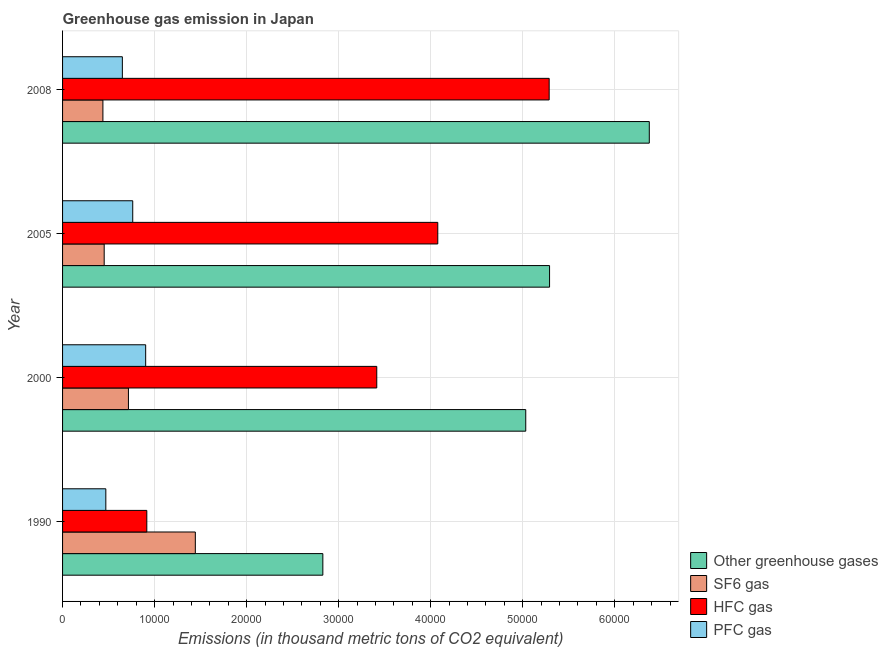How many groups of bars are there?
Give a very brief answer. 4. Are the number of bars per tick equal to the number of legend labels?
Offer a terse response. Yes. Are the number of bars on each tick of the Y-axis equal?
Provide a succinct answer. Yes. How many bars are there on the 1st tick from the bottom?
Offer a terse response. 4. In how many cases, is the number of bars for a given year not equal to the number of legend labels?
Your answer should be compact. 0. What is the emission of greenhouse gases in 2000?
Offer a terse response. 5.03e+04. Across all years, what is the maximum emission of pfc gas?
Your response must be concise. 9029.8. Across all years, what is the minimum emission of hfc gas?
Keep it short and to the point. 9154.3. In which year was the emission of pfc gas maximum?
Make the answer very short. 2000. What is the total emission of greenhouse gases in the graph?
Your response must be concise. 1.95e+05. What is the difference between the emission of greenhouse gases in 2000 and that in 2005?
Keep it short and to the point. -2588.2. What is the difference between the emission of greenhouse gases in 2008 and the emission of pfc gas in 2005?
Give a very brief answer. 5.61e+04. What is the average emission of greenhouse gases per year?
Give a very brief answer. 4.88e+04. In the year 2005, what is the difference between the emission of sf6 gas and emission of greenhouse gases?
Offer a terse response. -4.84e+04. In how many years, is the emission of pfc gas greater than 40000 thousand metric tons?
Make the answer very short. 0. What is the ratio of the emission of hfc gas in 2000 to that in 2005?
Make the answer very short. 0.84. What is the difference between the highest and the second highest emission of hfc gas?
Ensure brevity in your answer.  1.21e+04. What is the difference between the highest and the lowest emission of sf6 gas?
Make the answer very short. 1.00e+04. In how many years, is the emission of greenhouse gases greater than the average emission of greenhouse gases taken over all years?
Keep it short and to the point. 3. Is it the case that in every year, the sum of the emission of hfc gas and emission of greenhouse gases is greater than the sum of emission of pfc gas and emission of sf6 gas?
Offer a terse response. Yes. What does the 1st bar from the top in 2000 represents?
Your answer should be compact. PFC gas. What does the 3rd bar from the bottom in 2008 represents?
Provide a succinct answer. HFC gas. How many bars are there?
Ensure brevity in your answer.  16. How many years are there in the graph?
Keep it short and to the point. 4. What is the difference between two consecutive major ticks on the X-axis?
Your response must be concise. 10000. Are the values on the major ticks of X-axis written in scientific E-notation?
Make the answer very short. No. Does the graph contain grids?
Your response must be concise. Yes. Where does the legend appear in the graph?
Your answer should be compact. Bottom right. How are the legend labels stacked?
Keep it short and to the point. Vertical. What is the title of the graph?
Offer a very short reply. Greenhouse gas emission in Japan. What is the label or title of the X-axis?
Your answer should be very brief. Emissions (in thousand metric tons of CO2 equivalent). What is the Emissions (in thousand metric tons of CO2 equivalent) in Other greenhouse gases in 1990?
Offer a terse response. 2.83e+04. What is the Emissions (in thousand metric tons of CO2 equivalent) in SF6 gas in 1990?
Keep it short and to the point. 1.44e+04. What is the Emissions (in thousand metric tons of CO2 equivalent) in HFC gas in 1990?
Offer a terse response. 9154.3. What is the Emissions (in thousand metric tons of CO2 equivalent) in PFC gas in 1990?
Make the answer very short. 4700. What is the Emissions (in thousand metric tons of CO2 equivalent) of Other greenhouse gases in 2000?
Make the answer very short. 5.03e+04. What is the Emissions (in thousand metric tons of CO2 equivalent) in SF6 gas in 2000?
Offer a terse response. 7156.6. What is the Emissions (in thousand metric tons of CO2 equivalent) of HFC gas in 2000?
Your answer should be compact. 3.41e+04. What is the Emissions (in thousand metric tons of CO2 equivalent) of PFC gas in 2000?
Offer a very short reply. 9029.8. What is the Emissions (in thousand metric tons of CO2 equivalent) of Other greenhouse gases in 2005?
Your answer should be very brief. 5.29e+04. What is the Emissions (in thousand metric tons of CO2 equivalent) in SF6 gas in 2005?
Your response must be concise. 4522.3. What is the Emissions (in thousand metric tons of CO2 equivalent) of HFC gas in 2005?
Your response must be concise. 4.08e+04. What is the Emissions (in thousand metric tons of CO2 equivalent) of PFC gas in 2005?
Your answer should be very brief. 7623.6. What is the Emissions (in thousand metric tons of CO2 equivalent) of Other greenhouse gases in 2008?
Provide a short and direct response. 6.38e+04. What is the Emissions (in thousand metric tons of CO2 equivalent) of SF6 gas in 2008?
Offer a terse response. 4382.7. What is the Emissions (in thousand metric tons of CO2 equivalent) of HFC gas in 2008?
Provide a succinct answer. 5.29e+04. What is the Emissions (in thousand metric tons of CO2 equivalent) of PFC gas in 2008?
Keep it short and to the point. 6496.1. Across all years, what is the maximum Emissions (in thousand metric tons of CO2 equivalent) of Other greenhouse gases?
Make the answer very short. 6.38e+04. Across all years, what is the maximum Emissions (in thousand metric tons of CO2 equivalent) of SF6 gas?
Ensure brevity in your answer.  1.44e+04. Across all years, what is the maximum Emissions (in thousand metric tons of CO2 equivalent) in HFC gas?
Make the answer very short. 5.29e+04. Across all years, what is the maximum Emissions (in thousand metric tons of CO2 equivalent) of PFC gas?
Provide a short and direct response. 9029.8. Across all years, what is the minimum Emissions (in thousand metric tons of CO2 equivalent) in Other greenhouse gases?
Offer a very short reply. 2.83e+04. Across all years, what is the minimum Emissions (in thousand metric tons of CO2 equivalent) of SF6 gas?
Provide a succinct answer. 4382.7. Across all years, what is the minimum Emissions (in thousand metric tons of CO2 equivalent) of HFC gas?
Provide a short and direct response. 9154.3. Across all years, what is the minimum Emissions (in thousand metric tons of CO2 equivalent) of PFC gas?
Provide a succinct answer. 4700. What is the total Emissions (in thousand metric tons of CO2 equivalent) of Other greenhouse gases in the graph?
Your answer should be compact. 1.95e+05. What is the total Emissions (in thousand metric tons of CO2 equivalent) in SF6 gas in the graph?
Offer a terse response. 3.05e+04. What is the total Emissions (in thousand metric tons of CO2 equivalent) in HFC gas in the graph?
Offer a terse response. 1.37e+05. What is the total Emissions (in thousand metric tons of CO2 equivalent) in PFC gas in the graph?
Your answer should be very brief. 2.78e+04. What is the difference between the Emissions (in thousand metric tons of CO2 equivalent) of Other greenhouse gases in 1990 and that in 2000?
Your answer should be very brief. -2.20e+04. What is the difference between the Emissions (in thousand metric tons of CO2 equivalent) of SF6 gas in 1990 and that in 2000?
Offer a very short reply. 7269.2. What is the difference between the Emissions (in thousand metric tons of CO2 equivalent) in HFC gas in 1990 and that in 2000?
Offer a terse response. -2.50e+04. What is the difference between the Emissions (in thousand metric tons of CO2 equivalent) in PFC gas in 1990 and that in 2000?
Provide a succinct answer. -4329.8. What is the difference between the Emissions (in thousand metric tons of CO2 equivalent) of Other greenhouse gases in 1990 and that in 2005?
Give a very brief answer. -2.46e+04. What is the difference between the Emissions (in thousand metric tons of CO2 equivalent) in SF6 gas in 1990 and that in 2005?
Give a very brief answer. 9903.5. What is the difference between the Emissions (in thousand metric tons of CO2 equivalent) of HFC gas in 1990 and that in 2005?
Provide a succinct answer. -3.16e+04. What is the difference between the Emissions (in thousand metric tons of CO2 equivalent) of PFC gas in 1990 and that in 2005?
Offer a terse response. -2923.6. What is the difference between the Emissions (in thousand metric tons of CO2 equivalent) of Other greenhouse gases in 1990 and that in 2008?
Provide a short and direct response. -3.55e+04. What is the difference between the Emissions (in thousand metric tons of CO2 equivalent) of SF6 gas in 1990 and that in 2008?
Offer a very short reply. 1.00e+04. What is the difference between the Emissions (in thousand metric tons of CO2 equivalent) of HFC gas in 1990 and that in 2008?
Your answer should be very brief. -4.37e+04. What is the difference between the Emissions (in thousand metric tons of CO2 equivalent) in PFC gas in 1990 and that in 2008?
Ensure brevity in your answer.  -1796.1. What is the difference between the Emissions (in thousand metric tons of CO2 equivalent) of Other greenhouse gases in 2000 and that in 2005?
Provide a short and direct response. -2588.2. What is the difference between the Emissions (in thousand metric tons of CO2 equivalent) of SF6 gas in 2000 and that in 2005?
Provide a short and direct response. 2634.3. What is the difference between the Emissions (in thousand metric tons of CO2 equivalent) in HFC gas in 2000 and that in 2005?
Your answer should be very brief. -6628.7. What is the difference between the Emissions (in thousand metric tons of CO2 equivalent) of PFC gas in 2000 and that in 2005?
Keep it short and to the point. 1406.2. What is the difference between the Emissions (in thousand metric tons of CO2 equivalent) in Other greenhouse gases in 2000 and that in 2008?
Offer a very short reply. -1.34e+04. What is the difference between the Emissions (in thousand metric tons of CO2 equivalent) in SF6 gas in 2000 and that in 2008?
Offer a very short reply. 2773.9. What is the difference between the Emissions (in thousand metric tons of CO2 equivalent) of HFC gas in 2000 and that in 2008?
Make the answer very short. -1.87e+04. What is the difference between the Emissions (in thousand metric tons of CO2 equivalent) in PFC gas in 2000 and that in 2008?
Offer a very short reply. 2533.7. What is the difference between the Emissions (in thousand metric tons of CO2 equivalent) in Other greenhouse gases in 2005 and that in 2008?
Ensure brevity in your answer.  -1.08e+04. What is the difference between the Emissions (in thousand metric tons of CO2 equivalent) in SF6 gas in 2005 and that in 2008?
Make the answer very short. 139.6. What is the difference between the Emissions (in thousand metric tons of CO2 equivalent) of HFC gas in 2005 and that in 2008?
Your answer should be compact. -1.21e+04. What is the difference between the Emissions (in thousand metric tons of CO2 equivalent) in PFC gas in 2005 and that in 2008?
Offer a terse response. 1127.5. What is the difference between the Emissions (in thousand metric tons of CO2 equivalent) of Other greenhouse gases in 1990 and the Emissions (in thousand metric tons of CO2 equivalent) of SF6 gas in 2000?
Your answer should be very brief. 2.11e+04. What is the difference between the Emissions (in thousand metric tons of CO2 equivalent) of Other greenhouse gases in 1990 and the Emissions (in thousand metric tons of CO2 equivalent) of HFC gas in 2000?
Offer a very short reply. -5859.7. What is the difference between the Emissions (in thousand metric tons of CO2 equivalent) in Other greenhouse gases in 1990 and the Emissions (in thousand metric tons of CO2 equivalent) in PFC gas in 2000?
Give a very brief answer. 1.93e+04. What is the difference between the Emissions (in thousand metric tons of CO2 equivalent) of SF6 gas in 1990 and the Emissions (in thousand metric tons of CO2 equivalent) of HFC gas in 2000?
Offer a very short reply. -1.97e+04. What is the difference between the Emissions (in thousand metric tons of CO2 equivalent) in SF6 gas in 1990 and the Emissions (in thousand metric tons of CO2 equivalent) in PFC gas in 2000?
Provide a short and direct response. 5396. What is the difference between the Emissions (in thousand metric tons of CO2 equivalent) in HFC gas in 1990 and the Emissions (in thousand metric tons of CO2 equivalent) in PFC gas in 2000?
Ensure brevity in your answer.  124.5. What is the difference between the Emissions (in thousand metric tons of CO2 equivalent) in Other greenhouse gases in 1990 and the Emissions (in thousand metric tons of CO2 equivalent) in SF6 gas in 2005?
Offer a very short reply. 2.38e+04. What is the difference between the Emissions (in thousand metric tons of CO2 equivalent) in Other greenhouse gases in 1990 and the Emissions (in thousand metric tons of CO2 equivalent) in HFC gas in 2005?
Make the answer very short. -1.25e+04. What is the difference between the Emissions (in thousand metric tons of CO2 equivalent) of Other greenhouse gases in 1990 and the Emissions (in thousand metric tons of CO2 equivalent) of PFC gas in 2005?
Keep it short and to the point. 2.07e+04. What is the difference between the Emissions (in thousand metric tons of CO2 equivalent) in SF6 gas in 1990 and the Emissions (in thousand metric tons of CO2 equivalent) in HFC gas in 2005?
Keep it short and to the point. -2.63e+04. What is the difference between the Emissions (in thousand metric tons of CO2 equivalent) of SF6 gas in 1990 and the Emissions (in thousand metric tons of CO2 equivalent) of PFC gas in 2005?
Ensure brevity in your answer.  6802.2. What is the difference between the Emissions (in thousand metric tons of CO2 equivalent) of HFC gas in 1990 and the Emissions (in thousand metric tons of CO2 equivalent) of PFC gas in 2005?
Provide a succinct answer. 1530.7. What is the difference between the Emissions (in thousand metric tons of CO2 equivalent) in Other greenhouse gases in 1990 and the Emissions (in thousand metric tons of CO2 equivalent) in SF6 gas in 2008?
Give a very brief answer. 2.39e+04. What is the difference between the Emissions (in thousand metric tons of CO2 equivalent) of Other greenhouse gases in 1990 and the Emissions (in thousand metric tons of CO2 equivalent) of HFC gas in 2008?
Ensure brevity in your answer.  -2.46e+04. What is the difference between the Emissions (in thousand metric tons of CO2 equivalent) in Other greenhouse gases in 1990 and the Emissions (in thousand metric tons of CO2 equivalent) in PFC gas in 2008?
Your response must be concise. 2.18e+04. What is the difference between the Emissions (in thousand metric tons of CO2 equivalent) in SF6 gas in 1990 and the Emissions (in thousand metric tons of CO2 equivalent) in HFC gas in 2008?
Give a very brief answer. -3.84e+04. What is the difference between the Emissions (in thousand metric tons of CO2 equivalent) in SF6 gas in 1990 and the Emissions (in thousand metric tons of CO2 equivalent) in PFC gas in 2008?
Give a very brief answer. 7929.7. What is the difference between the Emissions (in thousand metric tons of CO2 equivalent) in HFC gas in 1990 and the Emissions (in thousand metric tons of CO2 equivalent) in PFC gas in 2008?
Your answer should be very brief. 2658.2. What is the difference between the Emissions (in thousand metric tons of CO2 equivalent) of Other greenhouse gases in 2000 and the Emissions (in thousand metric tons of CO2 equivalent) of SF6 gas in 2005?
Provide a short and direct response. 4.58e+04. What is the difference between the Emissions (in thousand metric tons of CO2 equivalent) of Other greenhouse gases in 2000 and the Emissions (in thousand metric tons of CO2 equivalent) of HFC gas in 2005?
Give a very brief answer. 9557.7. What is the difference between the Emissions (in thousand metric tons of CO2 equivalent) in Other greenhouse gases in 2000 and the Emissions (in thousand metric tons of CO2 equivalent) in PFC gas in 2005?
Give a very brief answer. 4.27e+04. What is the difference between the Emissions (in thousand metric tons of CO2 equivalent) of SF6 gas in 2000 and the Emissions (in thousand metric tons of CO2 equivalent) of HFC gas in 2005?
Keep it short and to the point. -3.36e+04. What is the difference between the Emissions (in thousand metric tons of CO2 equivalent) of SF6 gas in 2000 and the Emissions (in thousand metric tons of CO2 equivalent) of PFC gas in 2005?
Ensure brevity in your answer.  -467. What is the difference between the Emissions (in thousand metric tons of CO2 equivalent) in HFC gas in 2000 and the Emissions (in thousand metric tons of CO2 equivalent) in PFC gas in 2005?
Your response must be concise. 2.65e+04. What is the difference between the Emissions (in thousand metric tons of CO2 equivalent) in Other greenhouse gases in 2000 and the Emissions (in thousand metric tons of CO2 equivalent) in SF6 gas in 2008?
Provide a succinct answer. 4.59e+04. What is the difference between the Emissions (in thousand metric tons of CO2 equivalent) of Other greenhouse gases in 2000 and the Emissions (in thousand metric tons of CO2 equivalent) of HFC gas in 2008?
Ensure brevity in your answer.  -2545.7. What is the difference between the Emissions (in thousand metric tons of CO2 equivalent) of Other greenhouse gases in 2000 and the Emissions (in thousand metric tons of CO2 equivalent) of PFC gas in 2008?
Offer a terse response. 4.38e+04. What is the difference between the Emissions (in thousand metric tons of CO2 equivalent) in SF6 gas in 2000 and the Emissions (in thousand metric tons of CO2 equivalent) in HFC gas in 2008?
Your response must be concise. -4.57e+04. What is the difference between the Emissions (in thousand metric tons of CO2 equivalent) in SF6 gas in 2000 and the Emissions (in thousand metric tons of CO2 equivalent) in PFC gas in 2008?
Provide a short and direct response. 660.5. What is the difference between the Emissions (in thousand metric tons of CO2 equivalent) of HFC gas in 2000 and the Emissions (in thousand metric tons of CO2 equivalent) of PFC gas in 2008?
Give a very brief answer. 2.76e+04. What is the difference between the Emissions (in thousand metric tons of CO2 equivalent) of Other greenhouse gases in 2005 and the Emissions (in thousand metric tons of CO2 equivalent) of SF6 gas in 2008?
Keep it short and to the point. 4.85e+04. What is the difference between the Emissions (in thousand metric tons of CO2 equivalent) in Other greenhouse gases in 2005 and the Emissions (in thousand metric tons of CO2 equivalent) in HFC gas in 2008?
Offer a terse response. 42.5. What is the difference between the Emissions (in thousand metric tons of CO2 equivalent) in Other greenhouse gases in 2005 and the Emissions (in thousand metric tons of CO2 equivalent) in PFC gas in 2008?
Offer a terse response. 4.64e+04. What is the difference between the Emissions (in thousand metric tons of CO2 equivalent) in SF6 gas in 2005 and the Emissions (in thousand metric tons of CO2 equivalent) in HFC gas in 2008?
Make the answer very short. -4.83e+04. What is the difference between the Emissions (in thousand metric tons of CO2 equivalent) of SF6 gas in 2005 and the Emissions (in thousand metric tons of CO2 equivalent) of PFC gas in 2008?
Give a very brief answer. -1973.8. What is the difference between the Emissions (in thousand metric tons of CO2 equivalent) of HFC gas in 2005 and the Emissions (in thousand metric tons of CO2 equivalent) of PFC gas in 2008?
Ensure brevity in your answer.  3.43e+04. What is the average Emissions (in thousand metric tons of CO2 equivalent) of Other greenhouse gases per year?
Provide a short and direct response. 4.88e+04. What is the average Emissions (in thousand metric tons of CO2 equivalent) in SF6 gas per year?
Make the answer very short. 7621.85. What is the average Emissions (in thousand metric tons of CO2 equivalent) of HFC gas per year?
Offer a terse response. 3.42e+04. What is the average Emissions (in thousand metric tons of CO2 equivalent) in PFC gas per year?
Offer a very short reply. 6962.38. In the year 1990, what is the difference between the Emissions (in thousand metric tons of CO2 equivalent) in Other greenhouse gases and Emissions (in thousand metric tons of CO2 equivalent) in SF6 gas?
Offer a very short reply. 1.39e+04. In the year 1990, what is the difference between the Emissions (in thousand metric tons of CO2 equivalent) of Other greenhouse gases and Emissions (in thousand metric tons of CO2 equivalent) of HFC gas?
Provide a succinct answer. 1.91e+04. In the year 1990, what is the difference between the Emissions (in thousand metric tons of CO2 equivalent) in Other greenhouse gases and Emissions (in thousand metric tons of CO2 equivalent) in PFC gas?
Your response must be concise. 2.36e+04. In the year 1990, what is the difference between the Emissions (in thousand metric tons of CO2 equivalent) in SF6 gas and Emissions (in thousand metric tons of CO2 equivalent) in HFC gas?
Your answer should be very brief. 5271.5. In the year 1990, what is the difference between the Emissions (in thousand metric tons of CO2 equivalent) in SF6 gas and Emissions (in thousand metric tons of CO2 equivalent) in PFC gas?
Your response must be concise. 9725.8. In the year 1990, what is the difference between the Emissions (in thousand metric tons of CO2 equivalent) of HFC gas and Emissions (in thousand metric tons of CO2 equivalent) of PFC gas?
Offer a very short reply. 4454.3. In the year 2000, what is the difference between the Emissions (in thousand metric tons of CO2 equivalent) in Other greenhouse gases and Emissions (in thousand metric tons of CO2 equivalent) in SF6 gas?
Make the answer very short. 4.32e+04. In the year 2000, what is the difference between the Emissions (in thousand metric tons of CO2 equivalent) in Other greenhouse gases and Emissions (in thousand metric tons of CO2 equivalent) in HFC gas?
Provide a succinct answer. 1.62e+04. In the year 2000, what is the difference between the Emissions (in thousand metric tons of CO2 equivalent) in Other greenhouse gases and Emissions (in thousand metric tons of CO2 equivalent) in PFC gas?
Keep it short and to the point. 4.13e+04. In the year 2000, what is the difference between the Emissions (in thousand metric tons of CO2 equivalent) in SF6 gas and Emissions (in thousand metric tons of CO2 equivalent) in HFC gas?
Make the answer very short. -2.70e+04. In the year 2000, what is the difference between the Emissions (in thousand metric tons of CO2 equivalent) of SF6 gas and Emissions (in thousand metric tons of CO2 equivalent) of PFC gas?
Provide a succinct answer. -1873.2. In the year 2000, what is the difference between the Emissions (in thousand metric tons of CO2 equivalent) of HFC gas and Emissions (in thousand metric tons of CO2 equivalent) of PFC gas?
Provide a short and direct response. 2.51e+04. In the year 2005, what is the difference between the Emissions (in thousand metric tons of CO2 equivalent) in Other greenhouse gases and Emissions (in thousand metric tons of CO2 equivalent) in SF6 gas?
Your answer should be very brief. 4.84e+04. In the year 2005, what is the difference between the Emissions (in thousand metric tons of CO2 equivalent) of Other greenhouse gases and Emissions (in thousand metric tons of CO2 equivalent) of HFC gas?
Keep it short and to the point. 1.21e+04. In the year 2005, what is the difference between the Emissions (in thousand metric tons of CO2 equivalent) in Other greenhouse gases and Emissions (in thousand metric tons of CO2 equivalent) in PFC gas?
Your answer should be compact. 4.53e+04. In the year 2005, what is the difference between the Emissions (in thousand metric tons of CO2 equivalent) of SF6 gas and Emissions (in thousand metric tons of CO2 equivalent) of HFC gas?
Provide a succinct answer. -3.62e+04. In the year 2005, what is the difference between the Emissions (in thousand metric tons of CO2 equivalent) of SF6 gas and Emissions (in thousand metric tons of CO2 equivalent) of PFC gas?
Your answer should be very brief. -3101.3. In the year 2005, what is the difference between the Emissions (in thousand metric tons of CO2 equivalent) in HFC gas and Emissions (in thousand metric tons of CO2 equivalent) in PFC gas?
Your response must be concise. 3.31e+04. In the year 2008, what is the difference between the Emissions (in thousand metric tons of CO2 equivalent) in Other greenhouse gases and Emissions (in thousand metric tons of CO2 equivalent) in SF6 gas?
Offer a very short reply. 5.94e+04. In the year 2008, what is the difference between the Emissions (in thousand metric tons of CO2 equivalent) in Other greenhouse gases and Emissions (in thousand metric tons of CO2 equivalent) in HFC gas?
Provide a succinct answer. 1.09e+04. In the year 2008, what is the difference between the Emissions (in thousand metric tons of CO2 equivalent) in Other greenhouse gases and Emissions (in thousand metric tons of CO2 equivalent) in PFC gas?
Provide a short and direct response. 5.73e+04. In the year 2008, what is the difference between the Emissions (in thousand metric tons of CO2 equivalent) of SF6 gas and Emissions (in thousand metric tons of CO2 equivalent) of HFC gas?
Your response must be concise. -4.85e+04. In the year 2008, what is the difference between the Emissions (in thousand metric tons of CO2 equivalent) in SF6 gas and Emissions (in thousand metric tons of CO2 equivalent) in PFC gas?
Provide a short and direct response. -2113.4. In the year 2008, what is the difference between the Emissions (in thousand metric tons of CO2 equivalent) in HFC gas and Emissions (in thousand metric tons of CO2 equivalent) in PFC gas?
Offer a terse response. 4.64e+04. What is the ratio of the Emissions (in thousand metric tons of CO2 equivalent) in Other greenhouse gases in 1990 to that in 2000?
Ensure brevity in your answer.  0.56. What is the ratio of the Emissions (in thousand metric tons of CO2 equivalent) in SF6 gas in 1990 to that in 2000?
Ensure brevity in your answer.  2.02. What is the ratio of the Emissions (in thousand metric tons of CO2 equivalent) of HFC gas in 1990 to that in 2000?
Offer a very short reply. 0.27. What is the ratio of the Emissions (in thousand metric tons of CO2 equivalent) in PFC gas in 1990 to that in 2000?
Make the answer very short. 0.52. What is the ratio of the Emissions (in thousand metric tons of CO2 equivalent) in Other greenhouse gases in 1990 to that in 2005?
Offer a very short reply. 0.53. What is the ratio of the Emissions (in thousand metric tons of CO2 equivalent) in SF6 gas in 1990 to that in 2005?
Your answer should be compact. 3.19. What is the ratio of the Emissions (in thousand metric tons of CO2 equivalent) of HFC gas in 1990 to that in 2005?
Give a very brief answer. 0.22. What is the ratio of the Emissions (in thousand metric tons of CO2 equivalent) in PFC gas in 1990 to that in 2005?
Your answer should be very brief. 0.62. What is the ratio of the Emissions (in thousand metric tons of CO2 equivalent) in Other greenhouse gases in 1990 to that in 2008?
Your response must be concise. 0.44. What is the ratio of the Emissions (in thousand metric tons of CO2 equivalent) of SF6 gas in 1990 to that in 2008?
Your answer should be very brief. 3.29. What is the ratio of the Emissions (in thousand metric tons of CO2 equivalent) in HFC gas in 1990 to that in 2008?
Keep it short and to the point. 0.17. What is the ratio of the Emissions (in thousand metric tons of CO2 equivalent) in PFC gas in 1990 to that in 2008?
Offer a very short reply. 0.72. What is the ratio of the Emissions (in thousand metric tons of CO2 equivalent) of Other greenhouse gases in 2000 to that in 2005?
Your answer should be very brief. 0.95. What is the ratio of the Emissions (in thousand metric tons of CO2 equivalent) of SF6 gas in 2000 to that in 2005?
Ensure brevity in your answer.  1.58. What is the ratio of the Emissions (in thousand metric tons of CO2 equivalent) of HFC gas in 2000 to that in 2005?
Keep it short and to the point. 0.84. What is the ratio of the Emissions (in thousand metric tons of CO2 equivalent) of PFC gas in 2000 to that in 2005?
Provide a short and direct response. 1.18. What is the ratio of the Emissions (in thousand metric tons of CO2 equivalent) of Other greenhouse gases in 2000 to that in 2008?
Keep it short and to the point. 0.79. What is the ratio of the Emissions (in thousand metric tons of CO2 equivalent) in SF6 gas in 2000 to that in 2008?
Provide a short and direct response. 1.63. What is the ratio of the Emissions (in thousand metric tons of CO2 equivalent) of HFC gas in 2000 to that in 2008?
Your answer should be compact. 0.65. What is the ratio of the Emissions (in thousand metric tons of CO2 equivalent) in PFC gas in 2000 to that in 2008?
Keep it short and to the point. 1.39. What is the ratio of the Emissions (in thousand metric tons of CO2 equivalent) of Other greenhouse gases in 2005 to that in 2008?
Your answer should be very brief. 0.83. What is the ratio of the Emissions (in thousand metric tons of CO2 equivalent) in SF6 gas in 2005 to that in 2008?
Your answer should be compact. 1.03. What is the ratio of the Emissions (in thousand metric tons of CO2 equivalent) of HFC gas in 2005 to that in 2008?
Offer a very short reply. 0.77. What is the ratio of the Emissions (in thousand metric tons of CO2 equivalent) of PFC gas in 2005 to that in 2008?
Give a very brief answer. 1.17. What is the difference between the highest and the second highest Emissions (in thousand metric tons of CO2 equivalent) of Other greenhouse gases?
Offer a very short reply. 1.08e+04. What is the difference between the highest and the second highest Emissions (in thousand metric tons of CO2 equivalent) in SF6 gas?
Your answer should be compact. 7269.2. What is the difference between the highest and the second highest Emissions (in thousand metric tons of CO2 equivalent) of HFC gas?
Keep it short and to the point. 1.21e+04. What is the difference between the highest and the second highest Emissions (in thousand metric tons of CO2 equivalent) in PFC gas?
Keep it short and to the point. 1406.2. What is the difference between the highest and the lowest Emissions (in thousand metric tons of CO2 equivalent) of Other greenhouse gases?
Your response must be concise. 3.55e+04. What is the difference between the highest and the lowest Emissions (in thousand metric tons of CO2 equivalent) in SF6 gas?
Provide a succinct answer. 1.00e+04. What is the difference between the highest and the lowest Emissions (in thousand metric tons of CO2 equivalent) in HFC gas?
Provide a succinct answer. 4.37e+04. What is the difference between the highest and the lowest Emissions (in thousand metric tons of CO2 equivalent) in PFC gas?
Ensure brevity in your answer.  4329.8. 